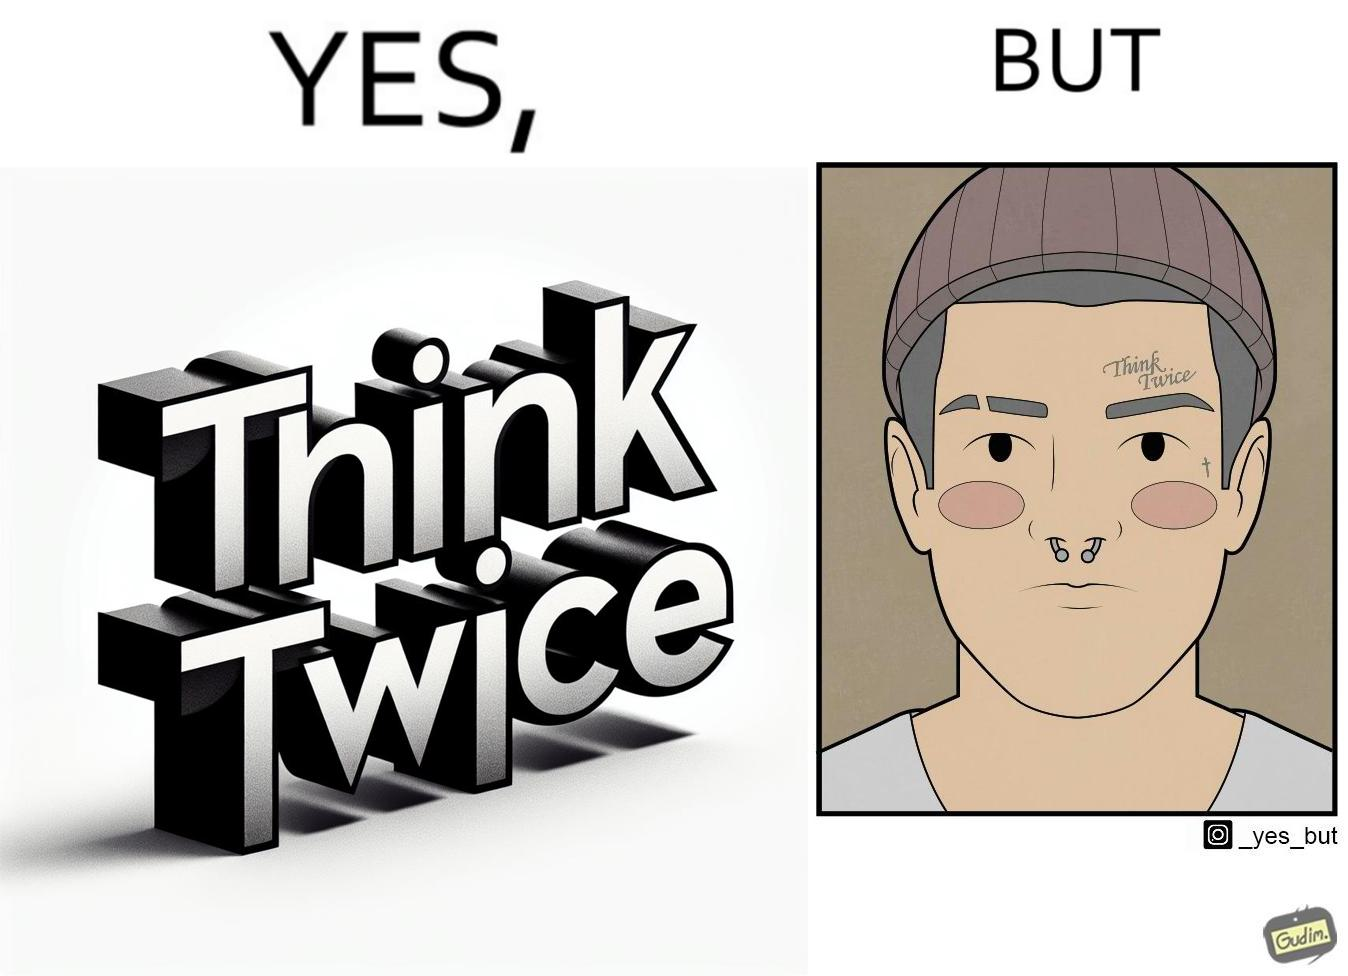Explain why this image is satirical. The image is funny because even thought the tattoo on the face of the man says "think twice", the man did not think twice before getting the tattoo on his forehead. 